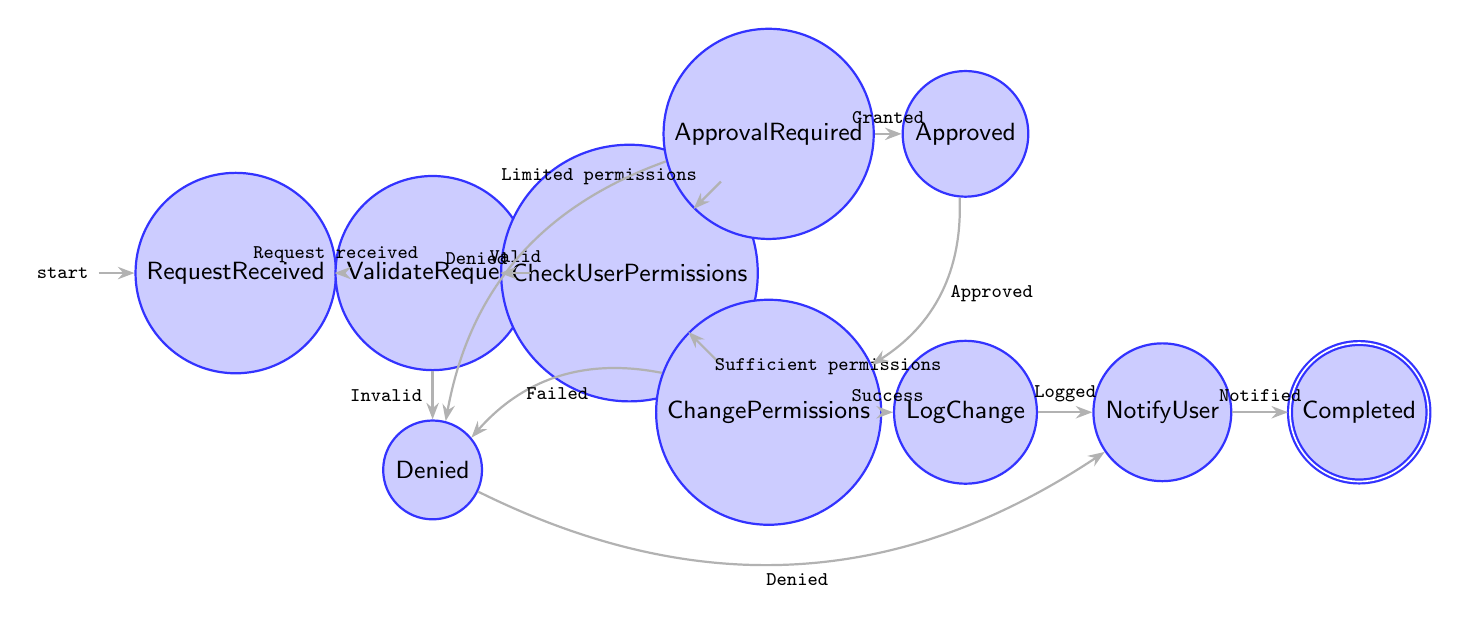What is the first state of the flow? The first state in the flow is indicated as the initial state, which is "RequestReceived".
Answer: RequestReceived How many states are there in total in the diagram? By counting each individual state node represented in the diagram, there are ten distinct states present.
Answer: 10 What state follows 'CheckUserPermissions' if the user has sufficient permissions? The diagram indicates that if the user has sufficient permissions, the flow moves to the "ChangePermissions" state.
Answer: ChangePermissions What is the next state after 'ChangePermissions' upon successful execution? Following the successful execution of permission changes in the "ChangePermissions" state, the flow transitions to the "LogChange" state.
Answer: LogChange In which state does the request go if the user’s permission change request is denied? If the permission change request is denied, the flow directs to the "Denied" state as shown in the diagram.
Answer: Denied What condition leads from 'ApprovalRequired' to 'Denied'? The condition that leads to the "Denied" state from "ApprovalRequired" is when the "Approval denied" scenario occurs.
Answer: Approval denied What happens after logging the change in 'LogChange'? After logging the changes made to permissions in the "LogChange" state, the flow proceeds to notify the user in the "NotifyUser" state.
Answer: NotifyUser What is the terminal state of the flow? The terminal state, which signifies the completion of the process, is represented as "Completed".
Answer: Completed Which state requires validation of the file permission change request details? The diagram specifies that the "ValidateRequest" state is responsible for validating the details of the file permission change request.
Answer: ValidateRequest What must happen for the flow to proceed from 'CheckUserPermissions' to 'ApprovalRequired'? For the transition from "CheckUserPermissions" to "ApprovalRequired" to occur, the user must have limited permissions as stated in the diagram.
Answer: Limited permissions 